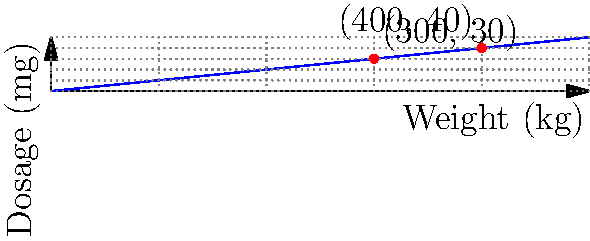Using the weight-based dosage chart for a marine antibiotic, calculate the correct dosage for a 350 kg sea lion. The chart shows a linear relationship between weight and dosage, with known points at (300 kg, 30 mg) and (400 kg, 40 mg). Round your answer to the nearest milligram. To solve this problem, we'll follow these steps:

1) First, we need to determine the relationship between weight and dosage. We can see from the chart that it's linear.

2) We can use the two known points to calculate the slope of this line:
   $$ \text{Slope} = \frac{\text{Change in Dosage}}{\text{Change in Weight}} = \frac{40 \text{ mg} - 30 \text{ mg}}{400 \text{ kg} - 300 \text{ kg}} = \frac{10 \text{ mg}}{100 \text{ kg}} = 0.1 \text{ mg/kg} $$

3) This means that for every 1 kg increase in weight, the dosage increases by 0.1 mg.

4) We can use the point-slope form of a line to write an equation for the dosage:
   $$ \text{Dosage} = 0.1 \times \text{Weight} + b $$

5) We can use either of the known points to find b. Let's use (300, 30):
   $$ 30 = 0.1 \times 300 + b $$
   $$ 30 = 30 + b $$
   $$ b = 0 $$

6) So our final equation is:
   $$ \text{Dosage} = 0.1 \times \text{Weight} $$

7) For a 350 kg sea lion:
   $$ \text{Dosage} = 0.1 \times 350 = 35 \text{ mg} $$

8) The question asks to round to the nearest milligram, but 35 mg is already a whole number.

Therefore, the correct dosage for a 350 kg sea lion is 35 mg.
Answer: 35 mg 